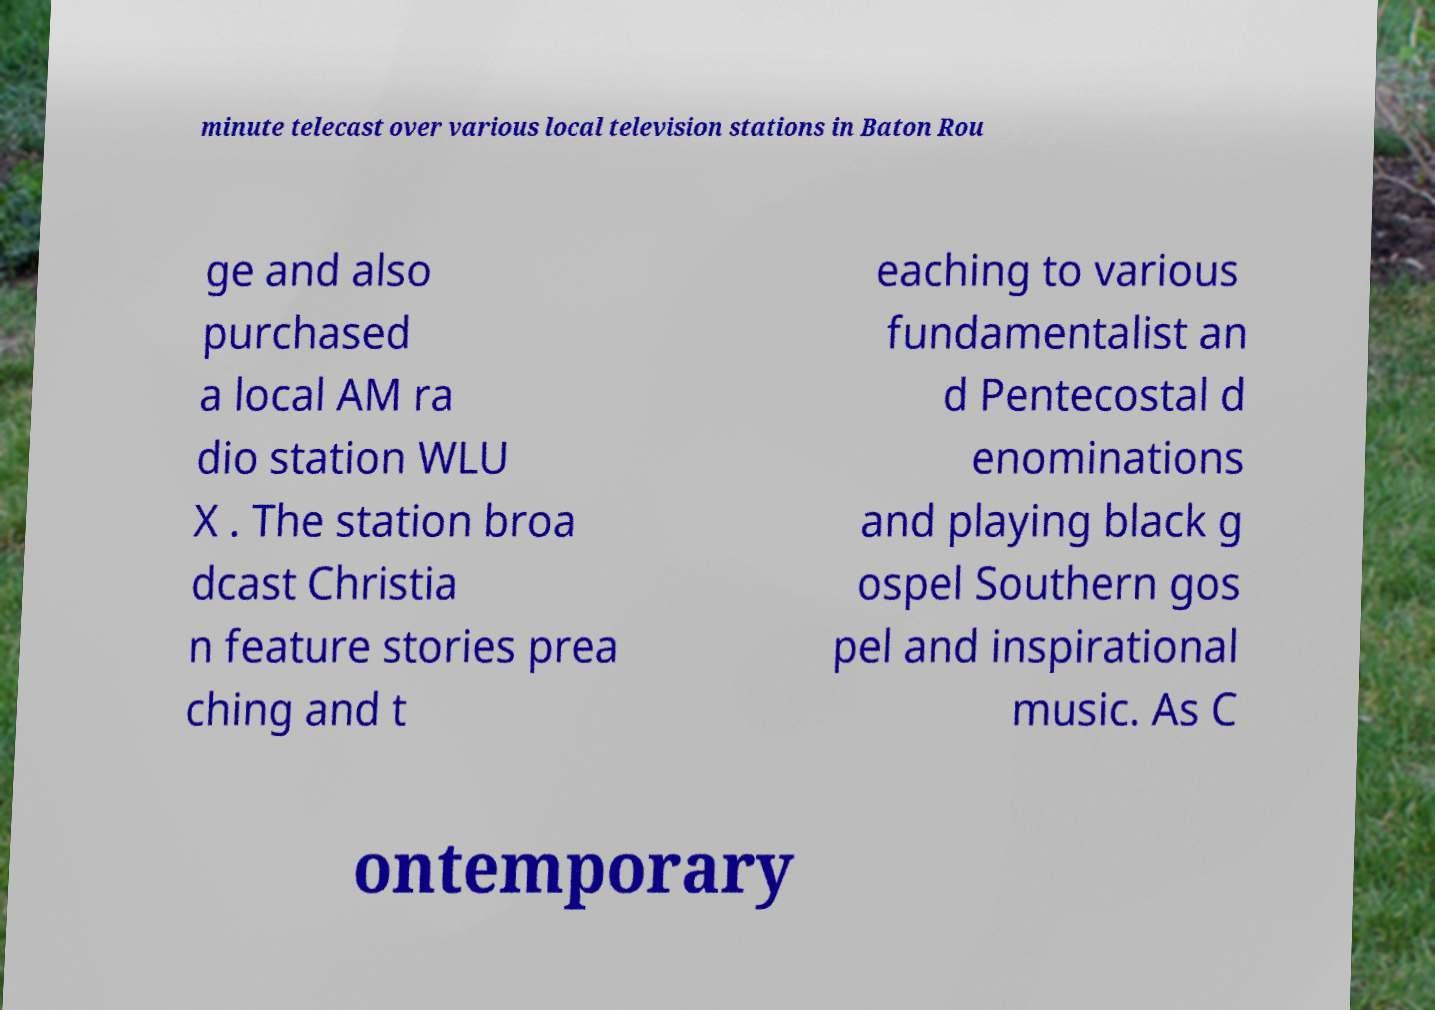There's text embedded in this image that I need extracted. Can you transcribe it verbatim? minute telecast over various local television stations in Baton Rou ge and also purchased a local AM ra dio station WLU X . The station broa dcast Christia n feature stories prea ching and t eaching to various fundamentalist an d Pentecostal d enominations and playing black g ospel Southern gos pel and inspirational music. As C ontemporary 